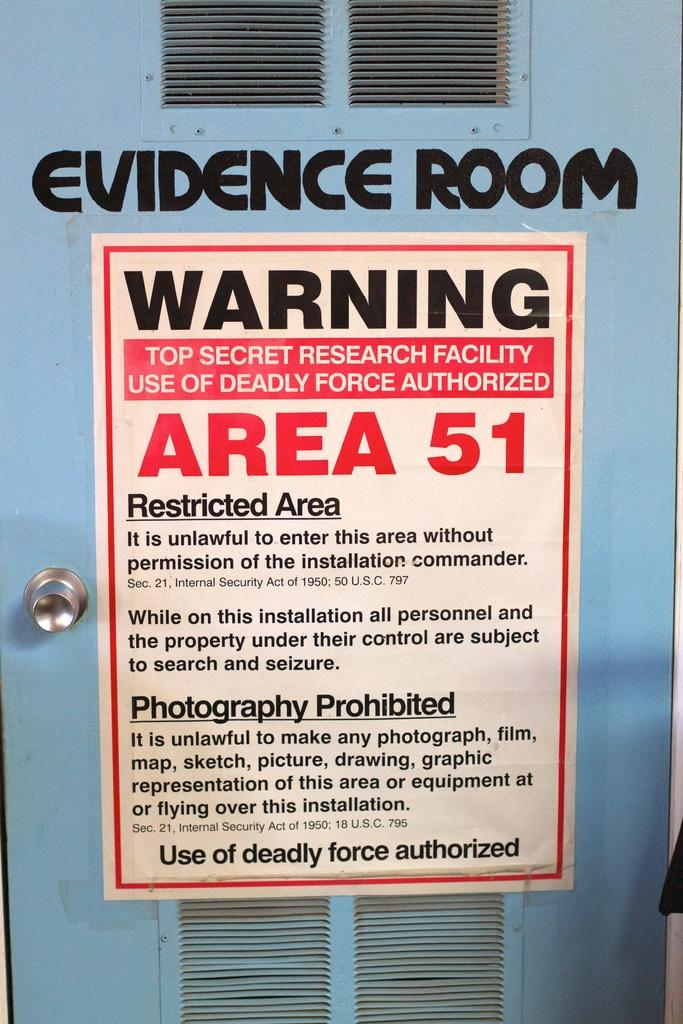<image>
Relay a brief, clear account of the picture shown. A door labeled evidence room, with a sign regarding Area 51 on it. 